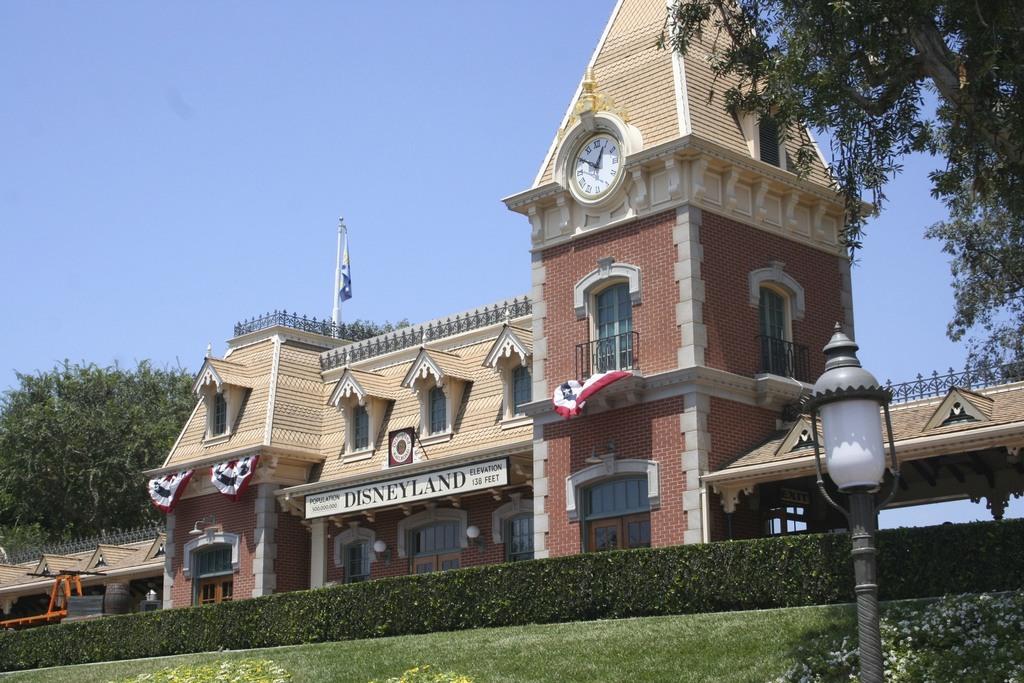What is displayed on the sign on the building?
Give a very brief answer. Disneyland. What is the name on the sign?
Offer a very short reply. Disneyland. 